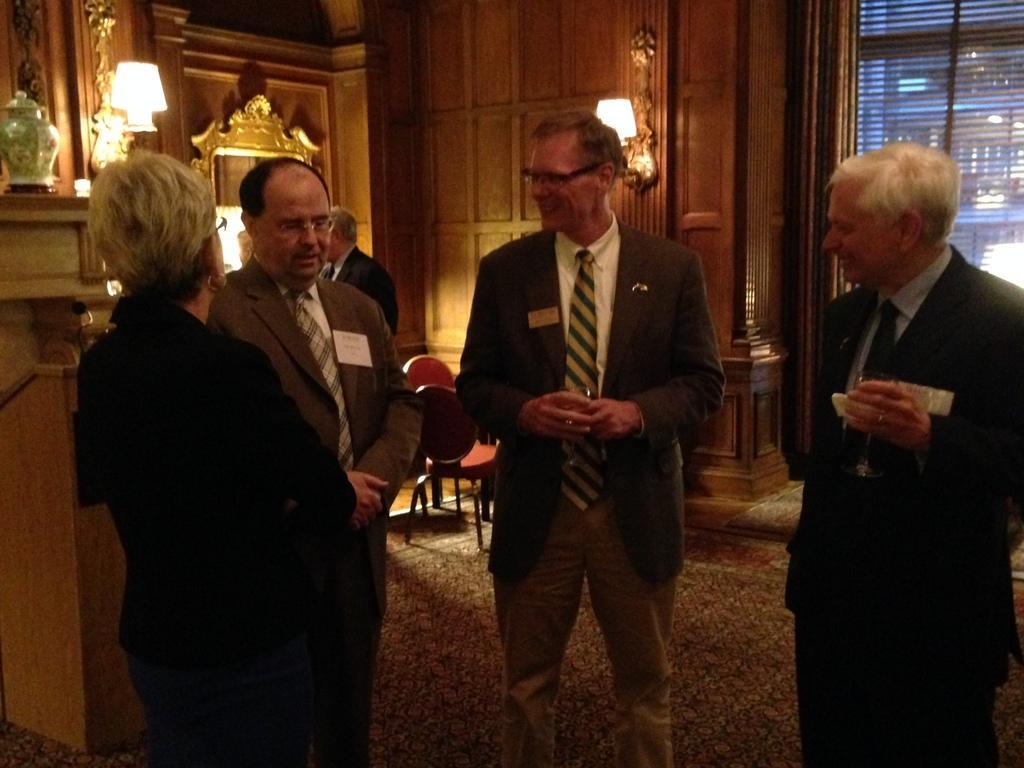How would you summarize this image in a sentence or two? In this image I can see few people are standing and I can see most of them are wearing suit, tie, shirt and pant. I can also see three of them are wearing specs and here I can see smile on his face. In the background I can see few lights and few chairs. 